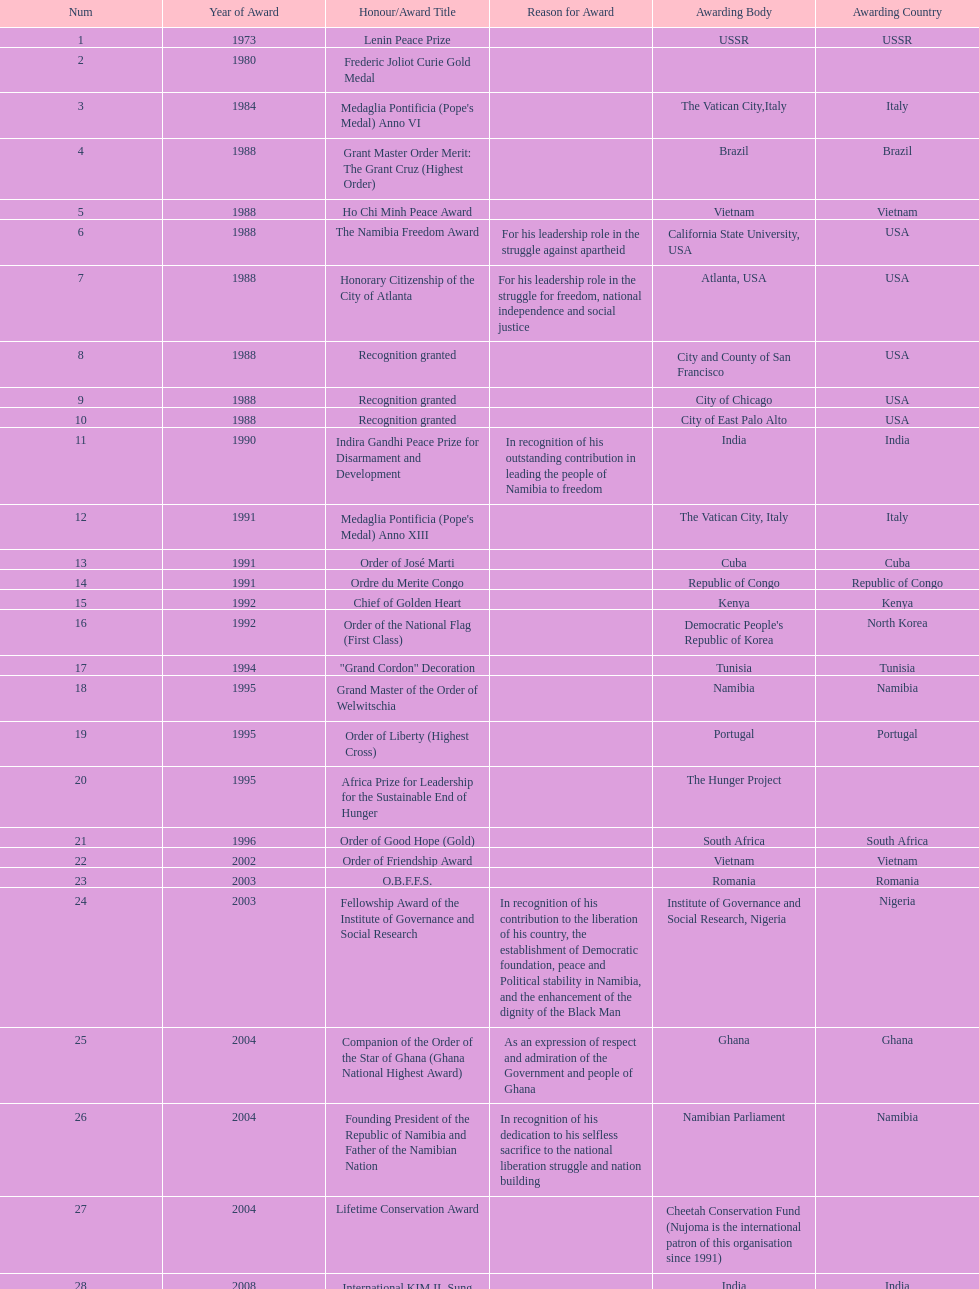What is the most recent award nujoma received? Sir Seretse Khama SADC Meda. 